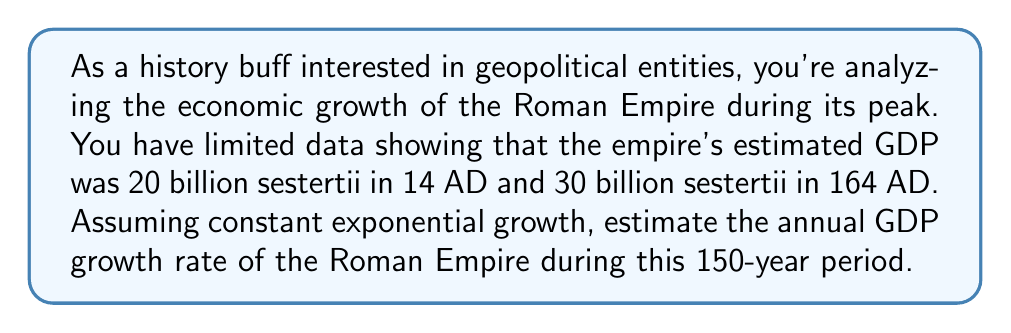Help me with this question. To solve this problem, we'll use the exponential growth formula and work backwards to find the growth rate. Let's approach this step-by-step:

1) The exponential growth formula is:
   $$ A = P(1 + r)^t $$
   Where:
   $A$ is the final amount
   $P$ is the initial amount
   $r$ is the annual growth rate (as a decimal)
   $t$ is the time in years

2) We know:
   $P = 20$ billion sestertii (14 AD)
   $A = 30$ billion sestertii (164 AD)
   $t = 164 - 14 = 150$ years

3) Plugging these into our formula:
   $$ 30 = 20(1 + r)^{150} $$

4) Dividing both sides by 20:
   $$ 1.5 = (1 + r)^{150} $$

5) Taking the 150th root of both sides:
   $$ \sqrt[150]{1.5} = 1 + r $$

6) Subtracting 1 from both sides:
   $$ \sqrt[150]{1.5} - 1 = r $$

7) Calculating this (you would use a calculator):
   $$ r \approx 0.00271 $$

8) Converting to a percentage:
   $$ 0.00271 \times 100\% \approx 0.271\% $$

Thus, the estimated annual GDP growth rate was approximately 0.271%.
Answer: 0.271% 